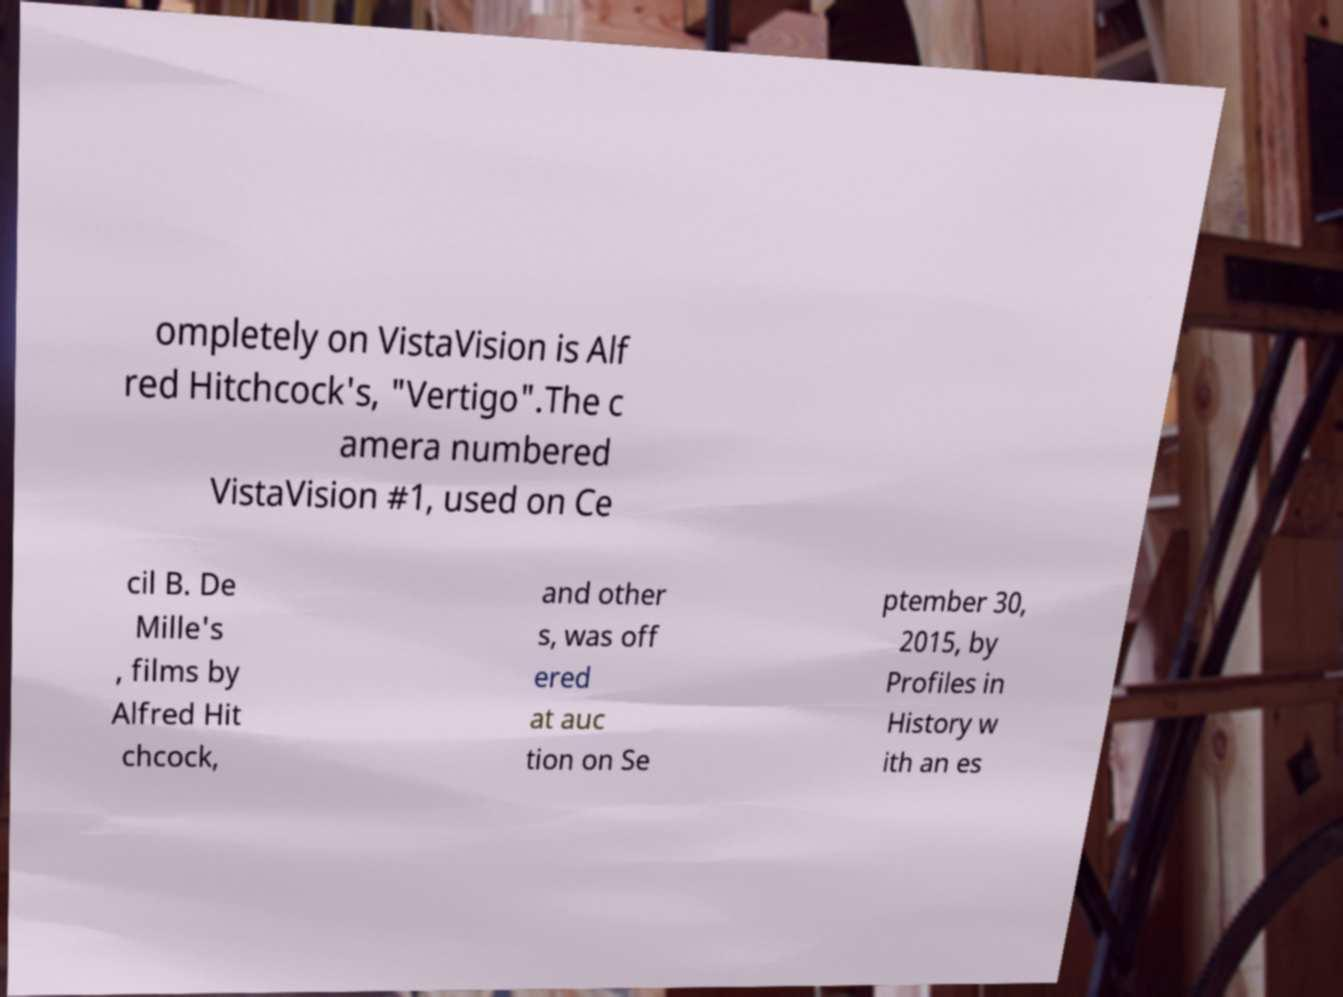Could you assist in decoding the text presented in this image and type it out clearly? ompletely on VistaVision is Alf red Hitchcock's, "Vertigo".The c amera numbered VistaVision #1, used on Ce cil B. De Mille's , films by Alfred Hit chcock, and other s, was off ered at auc tion on Se ptember 30, 2015, by Profiles in History w ith an es 